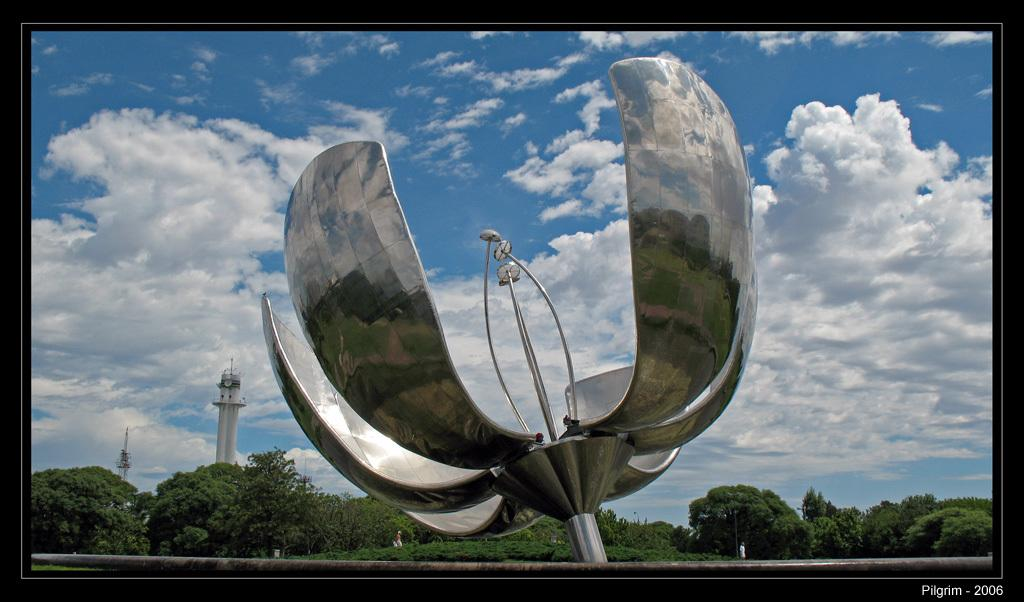What is the main subject in the center of the image? There is a statue in the center of the image. What can be seen in the background of the image? There is a tower and trees in the background of the image. What is visible in the sky in the image? The sky is visible in the background of the image, and there are clouds in the sky. How much grain is stored in the tower in the image? There is no indication of grain storage in the tower in the image. 